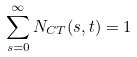<formula> <loc_0><loc_0><loc_500><loc_500>\sum _ { s = 0 } ^ { \infty } N _ { C T } ( s , t ) = 1</formula> 